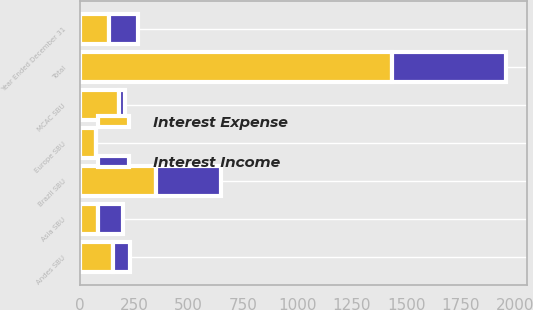Convert chart. <chart><loc_0><loc_0><loc_500><loc_500><stacked_bar_chart><ecel><fcel>Year Ended December 31<fcel>Andes SBU<fcel>Brazil SBU<fcel>MCAC SBU<fcel>Europe SBU<fcel>Asia SBU<fcel>Total<nl><fcel>Interest Income<fcel>134.5<fcel>77<fcel>299<fcel>30<fcel>1<fcel>115<fcel>524<nl><fcel>Interest Expense<fcel>134.5<fcel>154<fcel>349<fcel>179<fcel>73<fcel>85<fcel>1436<nl></chart> 